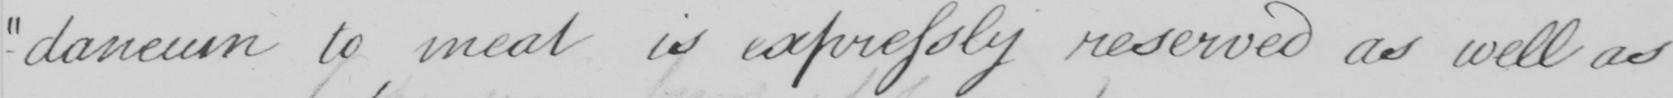Can you tell me what this handwritten text says? -daneum to meat is expressly reserved as well as 